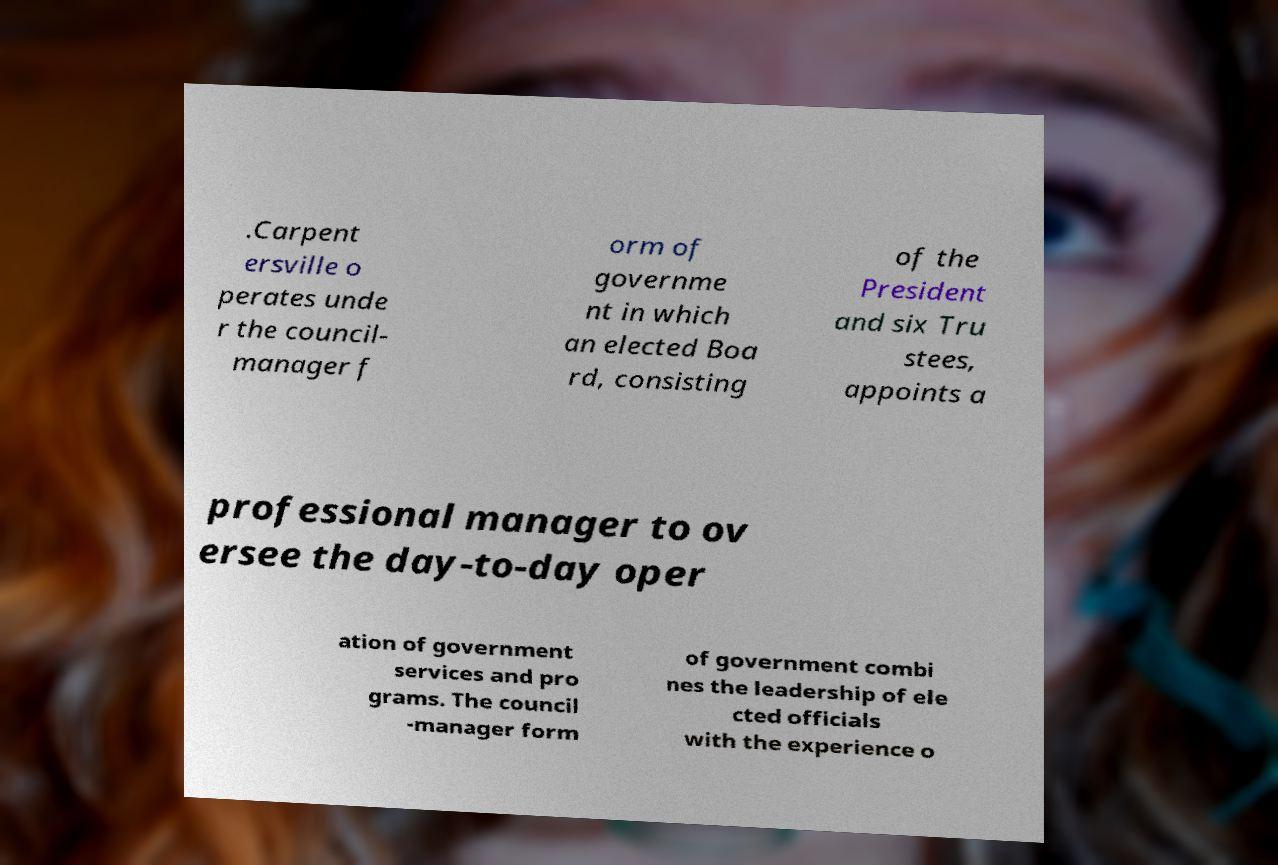I need the written content from this picture converted into text. Can you do that? .Carpent ersville o perates unde r the council- manager f orm of governme nt in which an elected Boa rd, consisting of the President and six Tru stees, appoints a professional manager to ov ersee the day-to-day oper ation of government services and pro grams. The council -manager form of government combi nes the leadership of ele cted officials with the experience o 